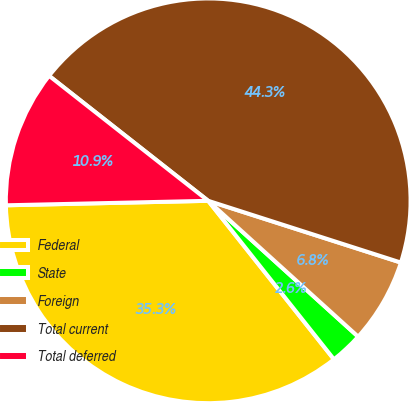Convert chart. <chart><loc_0><loc_0><loc_500><loc_500><pie_chart><fcel>Federal<fcel>State<fcel>Foreign<fcel>Total current<fcel>Total deferred<nl><fcel>35.32%<fcel>2.61%<fcel>6.78%<fcel>44.34%<fcel>10.95%<nl></chart> 